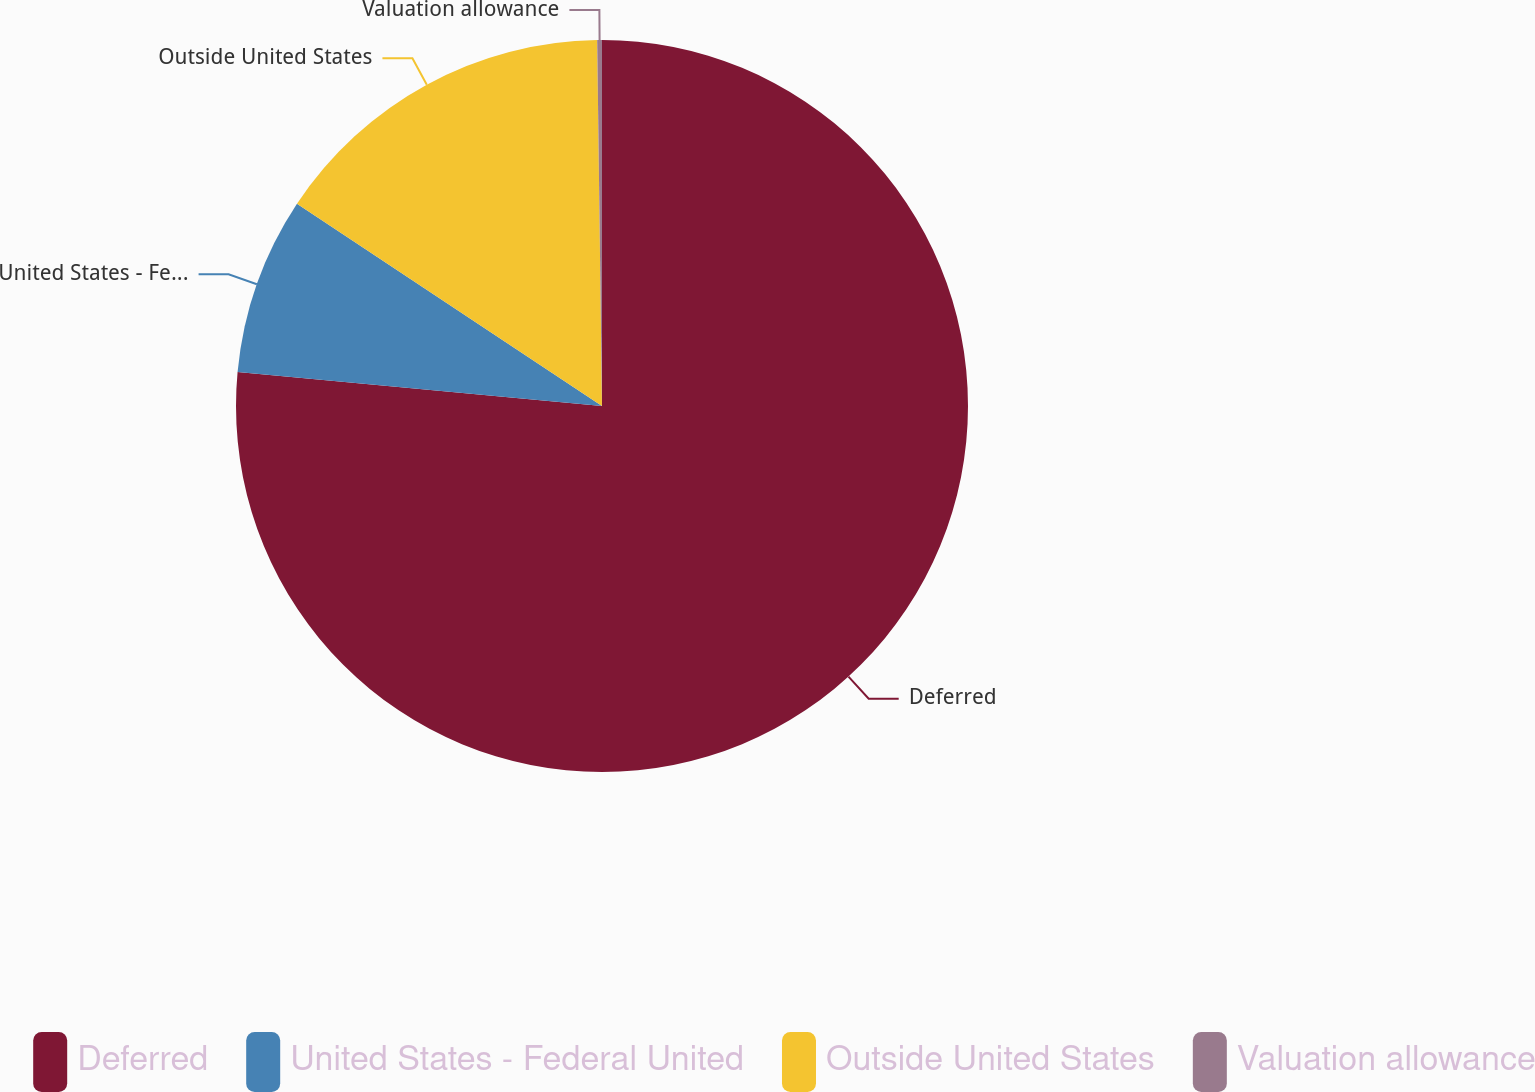Convert chart. <chart><loc_0><loc_0><loc_500><loc_500><pie_chart><fcel>Deferred<fcel>United States - Federal United<fcel>Outside United States<fcel>Valuation allowance<nl><fcel>76.48%<fcel>7.84%<fcel>15.47%<fcel>0.21%<nl></chart> 